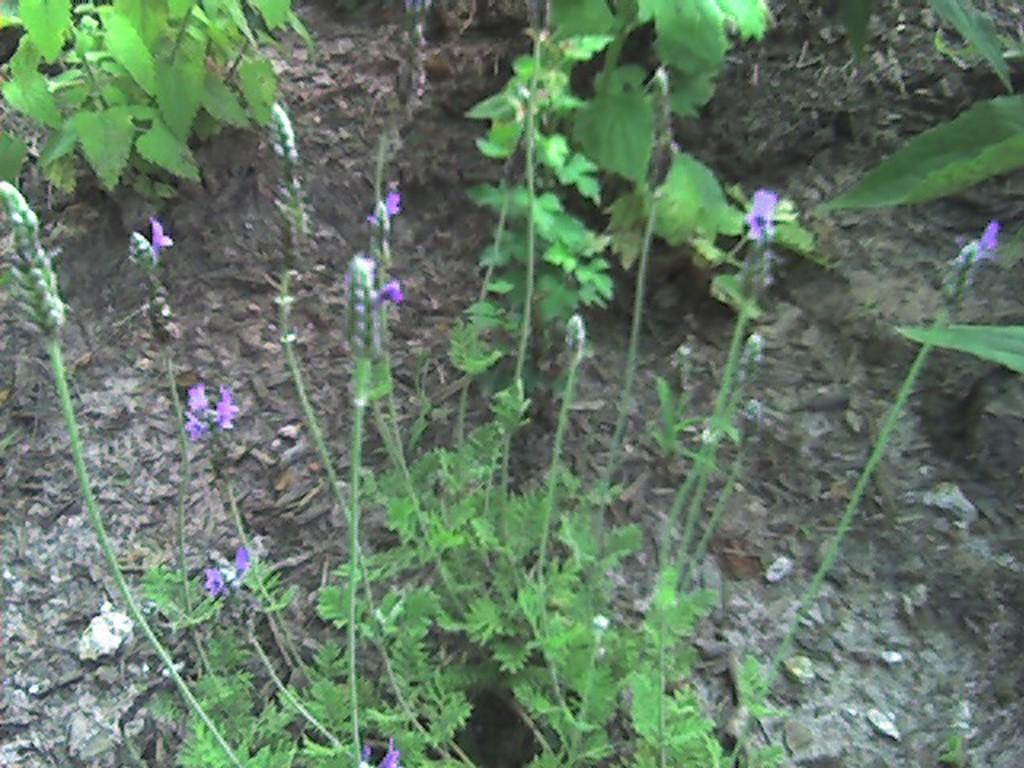What is located in the middle of the image? There are plants, flowers, buds, leaves, and stems visible in the middle of the image. What can be seen at the top of the image? There are plants present at the top of the image. What is visible in the background of the image? Land is visible in the background of the image. What type of creature can be heard making sounds in the image? There is no creature present in the image, and therefore no sounds can be heard. Is there any indication that someone is driving a vehicle in the image? There is no indication of a vehicle or driving in the image. 